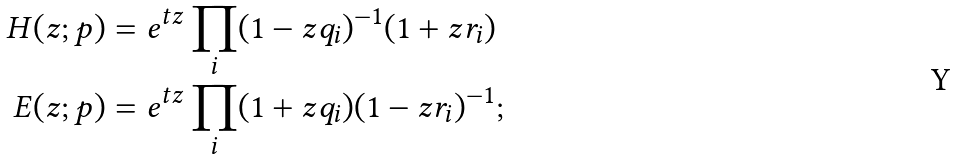<formula> <loc_0><loc_0><loc_500><loc_500>H ( z ; p ) & = e ^ { t z } \prod _ { i } ( 1 - z q _ { i } ) ^ { - 1 } ( 1 + z r _ { i } ) \\ E ( z ; p ) & = e ^ { t z } \prod _ { i } ( 1 + z q _ { i } ) ( 1 - z r _ { i } ) ^ { - 1 } ;</formula> 